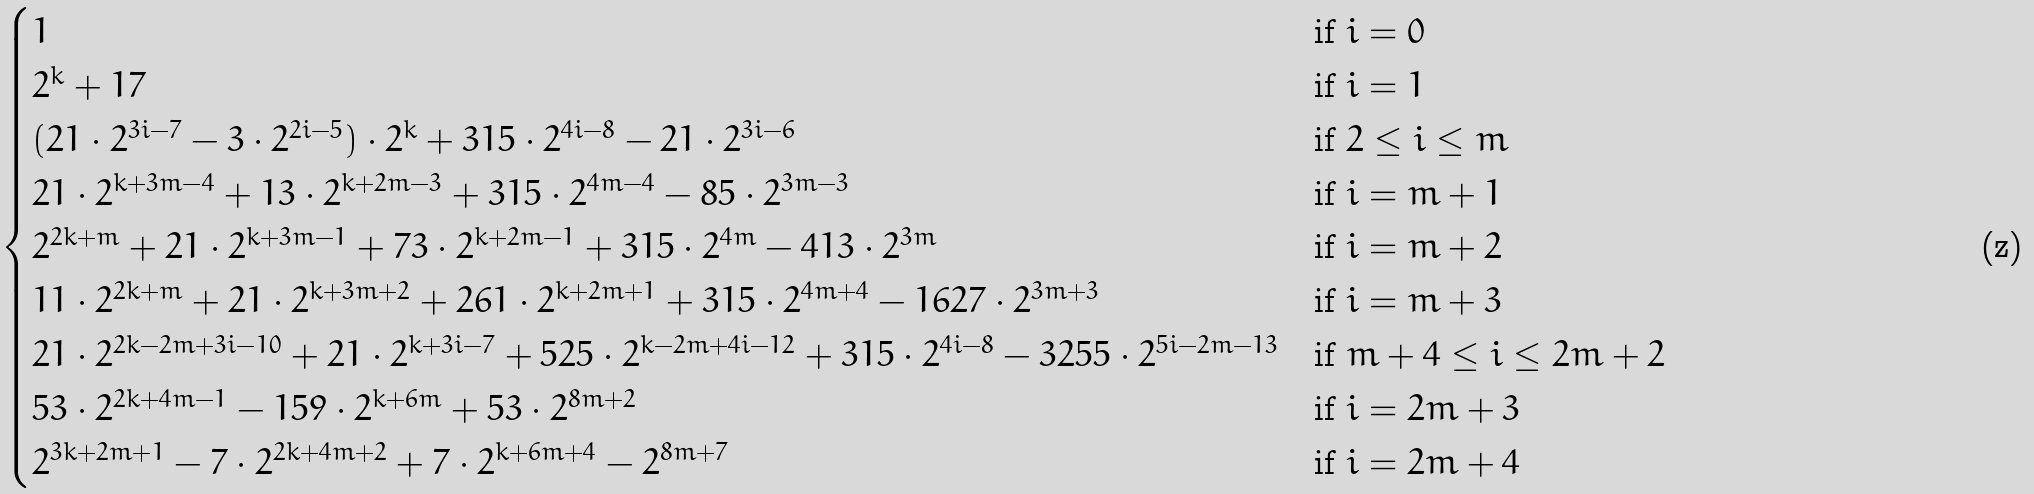Convert formula to latex. <formula><loc_0><loc_0><loc_500><loc_500>\begin{cases} 1 & \text {if  } i = 0 \\ 2 ^ { k } + 1 7 & \text {if  } i = 1 \\ ( 2 1 \cdot 2 ^ { 3 i - 7 } - 3 \cdot 2 ^ { 2 i - 5 } ) \cdot 2 ^ { k } + 3 1 5 \cdot 2 ^ { 4 i - 8 } - 2 1 \cdot 2 ^ { 3 i - 6 } & \text {if  } 2 \leq i \leq m \\ 2 1 \cdot 2 ^ { k + 3 m - 4 } + 1 3 \cdot 2 ^ { k + 2 m - 3 } + 3 1 5 \cdot 2 ^ { 4 m - 4 } - 8 5 \cdot 2 ^ { 3 m - 3 } & \text {if  } i = m + 1 \\ 2 ^ { 2 k + m } + 2 1 \cdot 2 ^ { k + 3 m - 1 } + 7 3 \cdot 2 ^ { k + 2 m - 1 } + 3 1 5 \cdot 2 ^ { 4 m } - 4 1 3 \cdot 2 ^ { 3 m } & \text {if  } i = m + 2 \\ 1 1 \cdot 2 ^ { 2 k + m } + 2 1 \cdot 2 ^ { k + 3 m + 2 } + 2 6 1 \cdot 2 ^ { k + 2 m + 1 } + 3 1 5 \cdot 2 ^ { 4 m + 4 } - 1 6 2 7 \cdot 2 ^ { 3 m + 3 } & \text {if  } i = m + 3 \\ 2 1 \cdot 2 ^ { 2 k - 2 m + 3 i - 1 0 } + 2 1 \cdot 2 ^ { k + 3 i - 7 } + 5 2 5 \cdot 2 ^ { k - 2 m + 4 i - 1 2 } + 3 1 5 \cdot 2 ^ { 4 i - 8 } - 3 2 5 5 \cdot 2 ^ { 5 i - 2 m - 1 3 } & \text {if  } m + 4 \leq i \leq 2 m + 2 \\ 5 3 \cdot 2 ^ { 2 k + 4 m - 1 } - 1 5 9 \cdot 2 ^ { k + 6 m } + 5 3 \cdot 2 ^ { 8 m + 2 } & \text {if  } i = 2 m + 3 \\ 2 ^ { 3 k + 2 m + 1 } - 7 \cdot 2 ^ { 2 k + 4 m + 2 } + 7 \cdot 2 ^ { k + 6 m + 4 } - 2 ^ { 8 m + 7 } & \text {if  } i = 2 m + 4 \end{cases}</formula> 